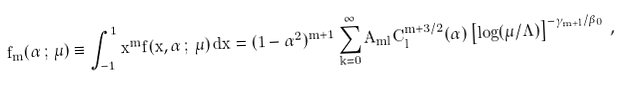Convert formula to latex. <formula><loc_0><loc_0><loc_500><loc_500>\tilde { f } _ { m } ( \alpha \, ; \, \mu ) \equiv \int _ { - 1 } ^ { 1 } x ^ { m } \tilde { f } ( x , \alpha \, ; \, \mu ) \, d x = ( 1 - \alpha ^ { 2 } ) ^ { m + 1 } \sum _ { k = 0 } ^ { \infty } A _ { m l } C _ { l } ^ { m + 3 / 2 } ( \alpha ) \left [ \log ( \mu / \Lambda ) \right ] ^ { - \gamma _ { m + l } / \beta _ { 0 } } \, ,</formula> 